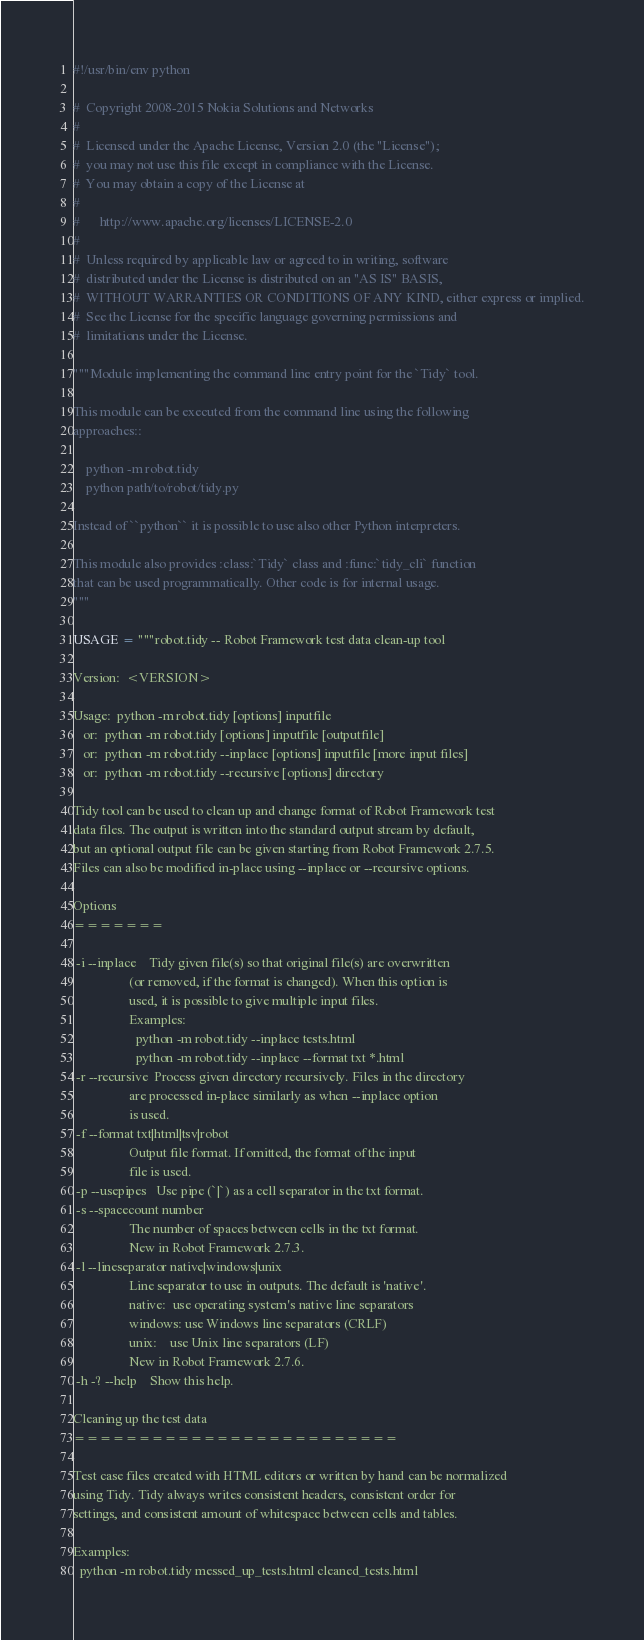<code> <loc_0><loc_0><loc_500><loc_500><_Python_>#!/usr/bin/env python

#  Copyright 2008-2015 Nokia Solutions and Networks
#
#  Licensed under the Apache License, Version 2.0 (the "License");
#  you may not use this file except in compliance with the License.
#  You may obtain a copy of the License at
#
#      http://www.apache.org/licenses/LICENSE-2.0
#
#  Unless required by applicable law or agreed to in writing, software
#  distributed under the License is distributed on an "AS IS" BASIS,
#  WITHOUT WARRANTIES OR CONDITIONS OF ANY KIND, either express or implied.
#  See the License for the specific language governing permissions and
#  limitations under the License.

"""Module implementing the command line entry point for the `Tidy` tool.

This module can be executed from the command line using the following
approaches::

    python -m robot.tidy
    python path/to/robot/tidy.py

Instead of ``python`` it is possible to use also other Python interpreters.

This module also provides :class:`Tidy` class and :func:`tidy_cli` function
that can be used programmatically. Other code is for internal usage.
"""

USAGE = """robot.tidy -- Robot Framework test data clean-up tool

Version:  <VERSION>

Usage:  python -m robot.tidy [options] inputfile
   or:  python -m robot.tidy [options] inputfile [outputfile]
   or:  python -m robot.tidy --inplace [options] inputfile [more input files]
   or:  python -m robot.tidy --recursive [options] directory

Tidy tool can be used to clean up and change format of Robot Framework test
data files. The output is written into the standard output stream by default,
but an optional output file can be given starting from Robot Framework 2.7.5.
Files can also be modified in-place using --inplace or --recursive options.

Options
=======

 -i --inplace    Tidy given file(s) so that original file(s) are overwritten
                 (or removed, if the format is changed). When this option is
                 used, it is possible to give multiple input files.
                 Examples:
                   python -m robot.tidy --inplace tests.html
                   python -m robot.tidy --inplace --format txt *.html
 -r --recursive  Process given directory recursively. Files in the directory
                 are processed in-place similarly as when --inplace option
                 is used.
 -f --format txt|html|tsv|robot
                 Output file format. If omitted, the format of the input
                 file is used.
 -p --usepipes   Use pipe (`|`) as a cell separator in the txt format.
 -s --spacecount number
                 The number of spaces between cells in the txt format.
                 New in Robot Framework 2.7.3.
 -l --lineseparator native|windows|unix
                 Line separator to use in outputs. The default is 'native'.
                 native:  use operating system's native line separators
                 windows: use Windows line separators (CRLF)
                 unix:    use Unix line separators (LF)
                 New in Robot Framework 2.7.6.
 -h -? --help    Show this help.

Cleaning up the test data
=========================

Test case files created with HTML editors or written by hand can be normalized
using Tidy. Tidy always writes consistent headers, consistent order for
settings, and consistent amount of whitespace between cells and tables.

Examples:
  python -m robot.tidy messed_up_tests.html cleaned_tests.html</code> 